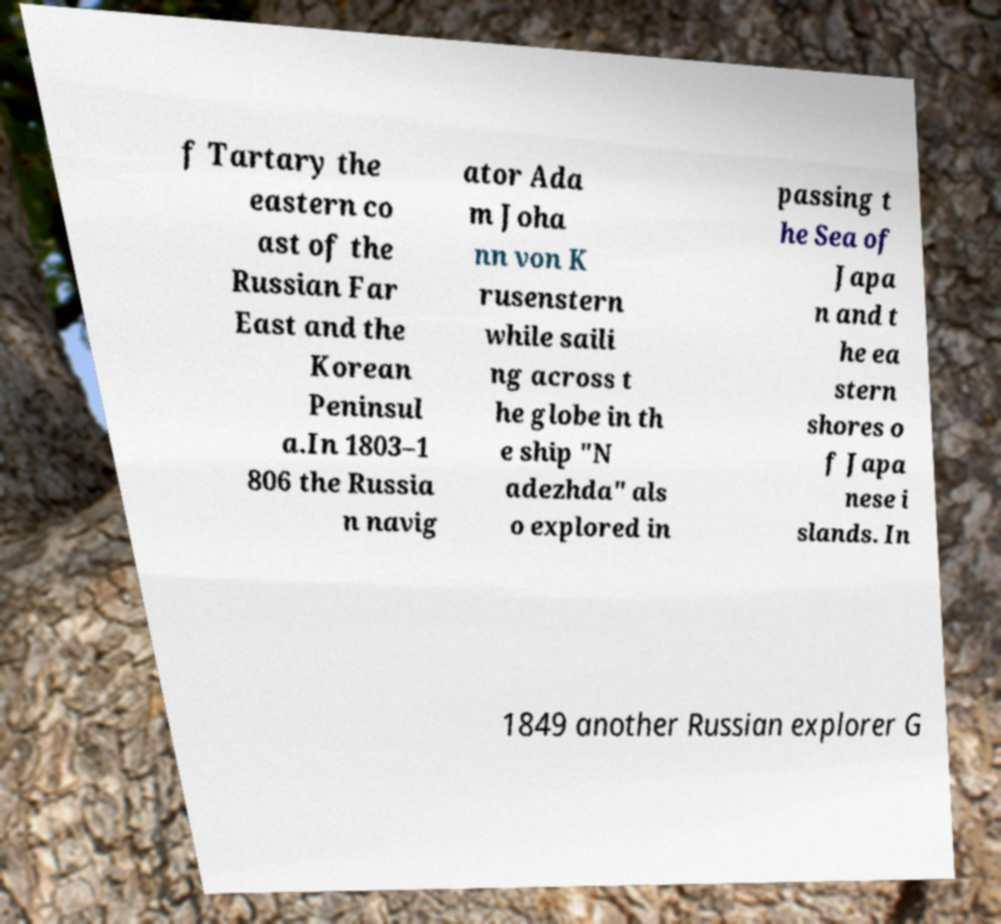Please identify and transcribe the text found in this image. f Tartary the eastern co ast of the Russian Far East and the Korean Peninsul a.In 1803–1 806 the Russia n navig ator Ada m Joha nn von K rusenstern while saili ng across t he globe in th e ship "N adezhda" als o explored in passing t he Sea of Japa n and t he ea stern shores o f Japa nese i slands. In 1849 another Russian explorer G 